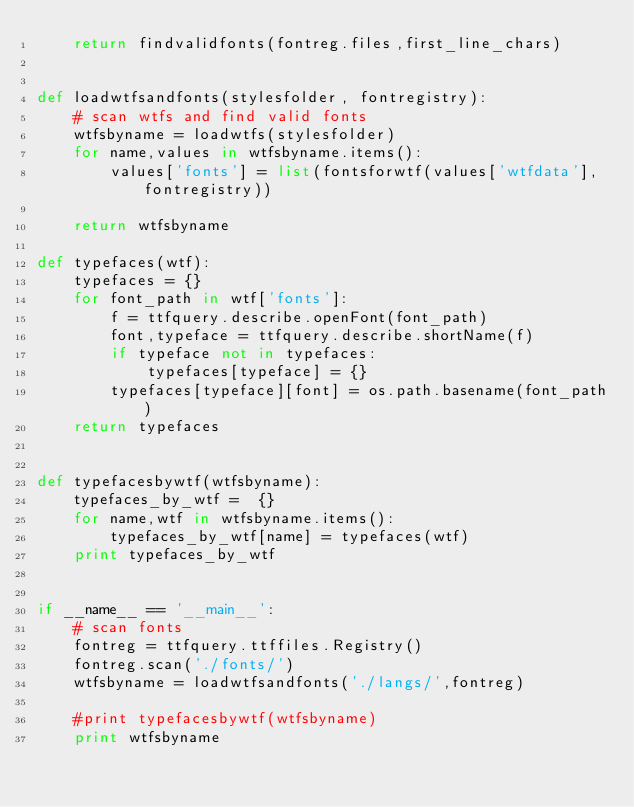<code> <loc_0><loc_0><loc_500><loc_500><_Python_>    return findvalidfonts(fontreg.files,first_line_chars)


def loadwtfsandfonts(stylesfolder, fontregistry):
    # scan wtfs and find valid fonts
    wtfsbyname = loadwtfs(stylesfolder)
    for name,values in wtfsbyname.items():
        values['fonts'] = list(fontsforwtf(values['wtfdata'], fontregistry))

    return wtfsbyname

def typefaces(wtf):
    typefaces = {}
    for font_path in wtf['fonts']:
        f = ttfquery.describe.openFont(font_path)
        font,typeface = ttfquery.describe.shortName(f)
        if typeface not in typefaces:
            typefaces[typeface] = {}
        typefaces[typeface][font] = os.path.basename(font_path)
    return typefaces


def typefacesbywtf(wtfsbyname):
    typefaces_by_wtf =  {}
    for name,wtf in wtfsbyname.items():
        typefaces_by_wtf[name] = typefaces(wtf)
    print typefaces_by_wtf


if __name__ == '__main__':
    # scan fonts
    fontreg = ttfquery.ttffiles.Registry()
    fontreg.scan('./fonts/')
    wtfsbyname = loadwtfsandfonts('./langs/',fontreg)

    #print typefacesbywtf(wtfsbyname)
    print wtfsbyname



</code> 